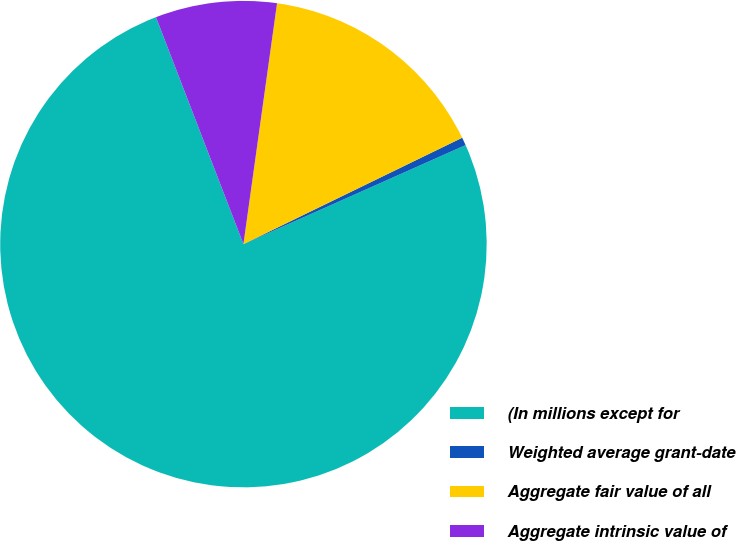Convert chart to OTSL. <chart><loc_0><loc_0><loc_500><loc_500><pie_chart><fcel>(In millions except for<fcel>Weighted average grant-date<fcel>Aggregate fair value of all<fcel>Aggregate intrinsic value of<nl><fcel>75.82%<fcel>0.53%<fcel>15.59%<fcel>8.06%<nl></chart> 